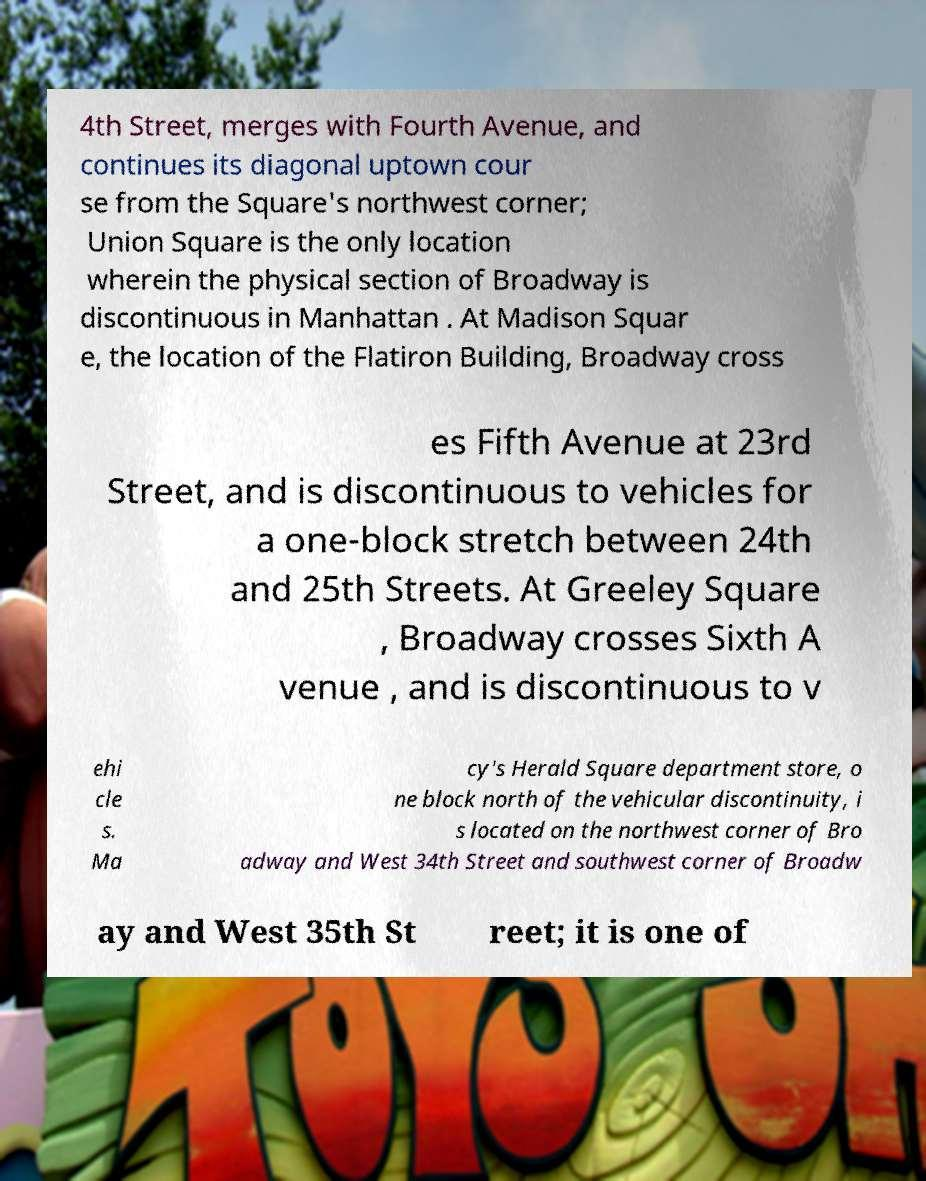Could you assist in decoding the text presented in this image and type it out clearly? 4th Street, merges with Fourth Avenue, and continues its diagonal uptown cour se from the Square's northwest corner; Union Square is the only location wherein the physical section of Broadway is discontinuous in Manhattan . At Madison Squar e, the location of the Flatiron Building, Broadway cross es Fifth Avenue at 23rd Street, and is discontinuous to vehicles for a one-block stretch between 24th and 25th Streets. At Greeley Square , Broadway crosses Sixth A venue , and is discontinuous to v ehi cle s. Ma cy's Herald Square department store, o ne block north of the vehicular discontinuity, i s located on the northwest corner of Bro adway and West 34th Street and southwest corner of Broadw ay and West 35th St reet; it is one of 